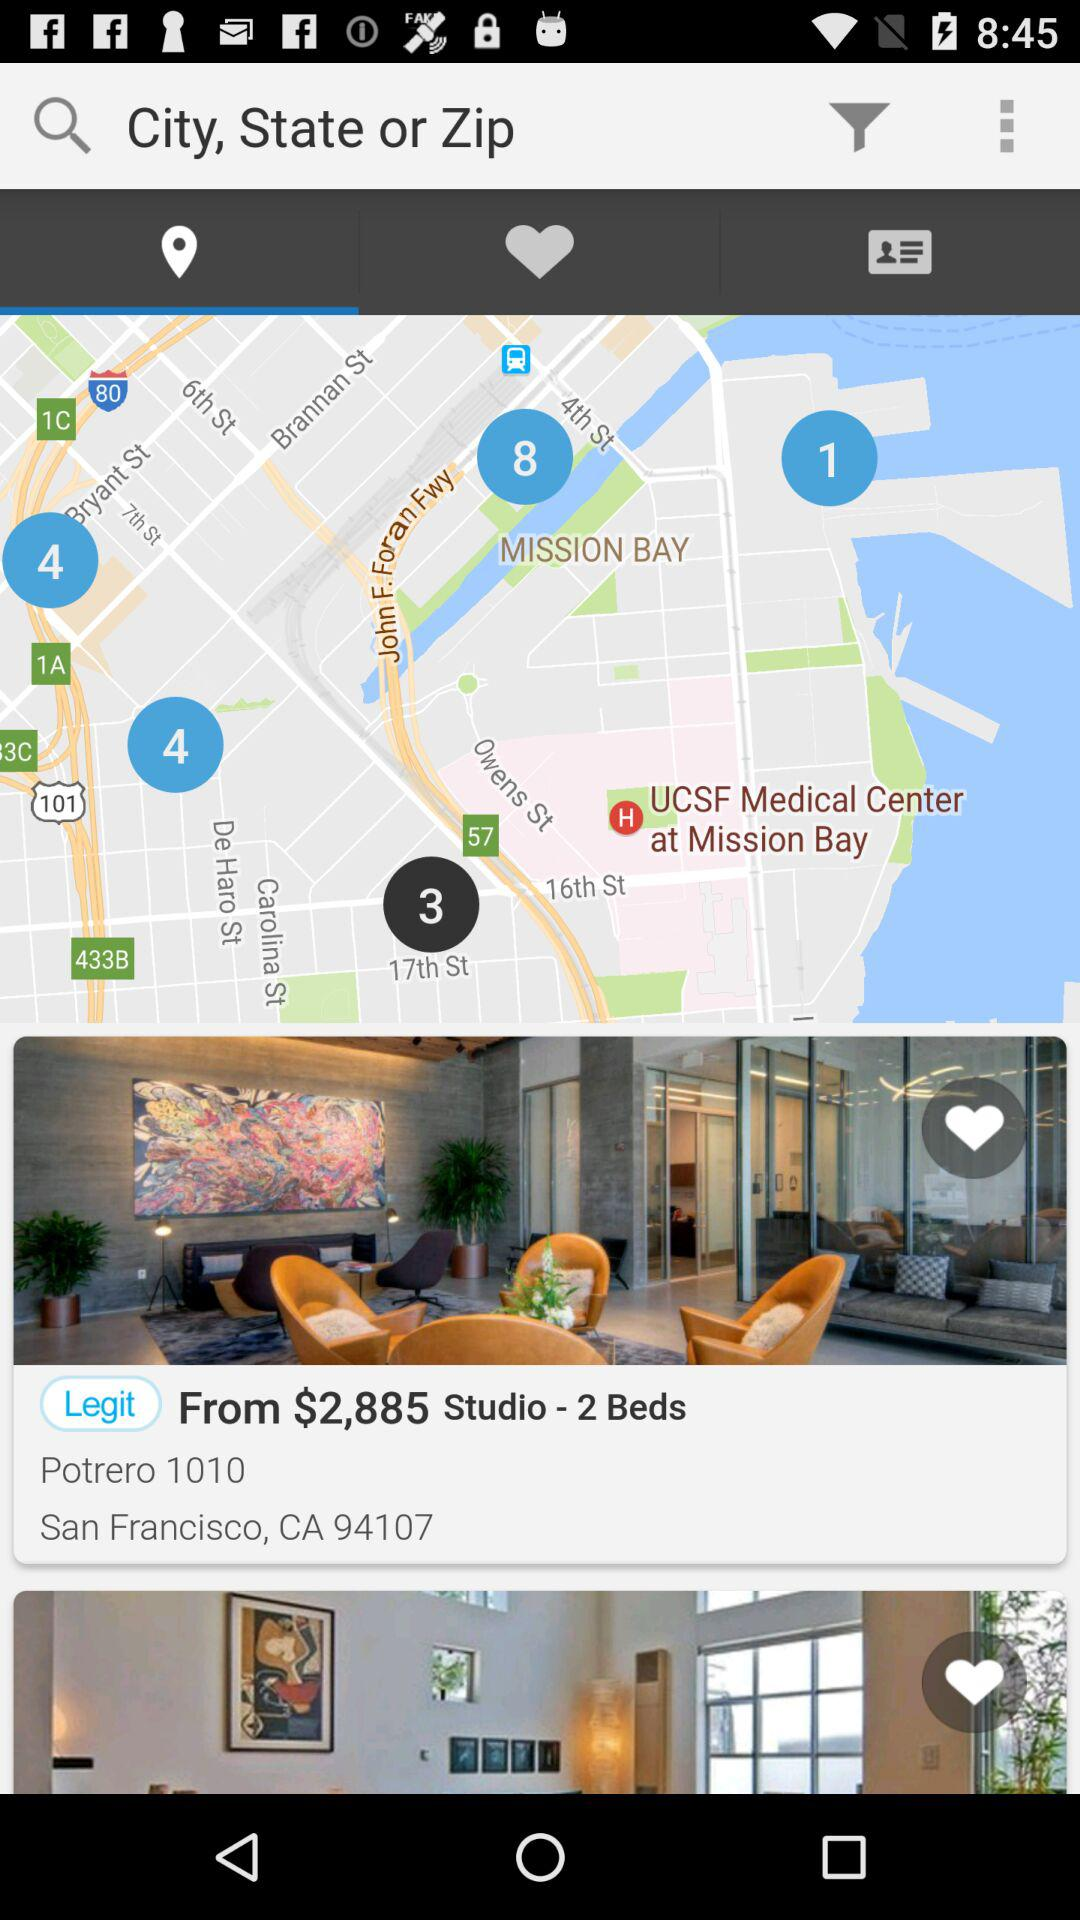What is the location of the studio? The location of the studio is San Francisco, CA 94107. 